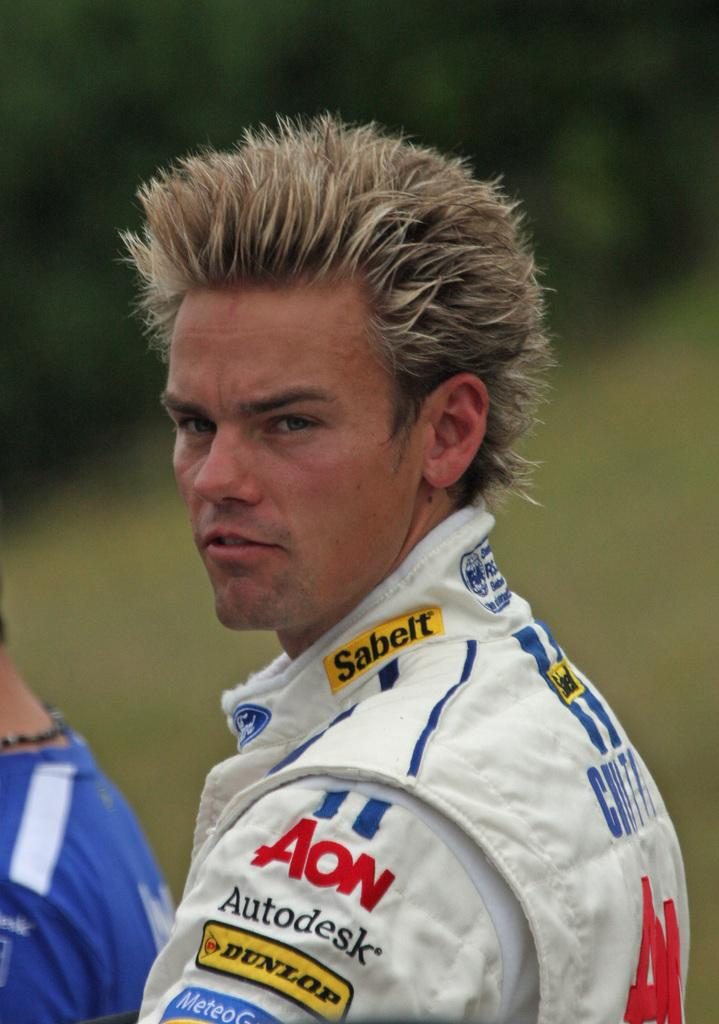<image>
Write a terse but informative summary of the picture. The man with spiky hair is sponsored by Autodesk. 